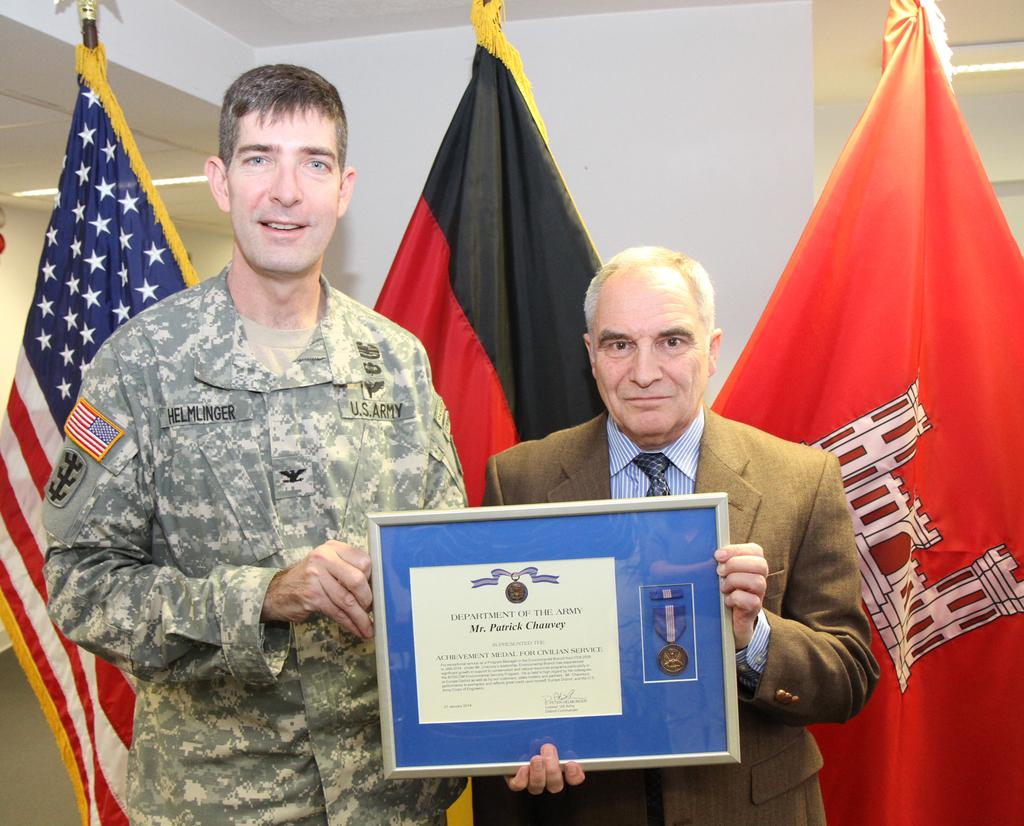How many people are in the image? There are two persons in the image. What are the two persons holding? The two persons are holding a frame. How many flags can be seen in the image? There are three flags visible in the image. What is the background of the image? There is a wall in the image. What type of harbor can be seen in the image? There is no harbor present in the image. What nation do the flags in the image represent? The flags in the image are not identified, so it cannot be determined which nation they represent. 